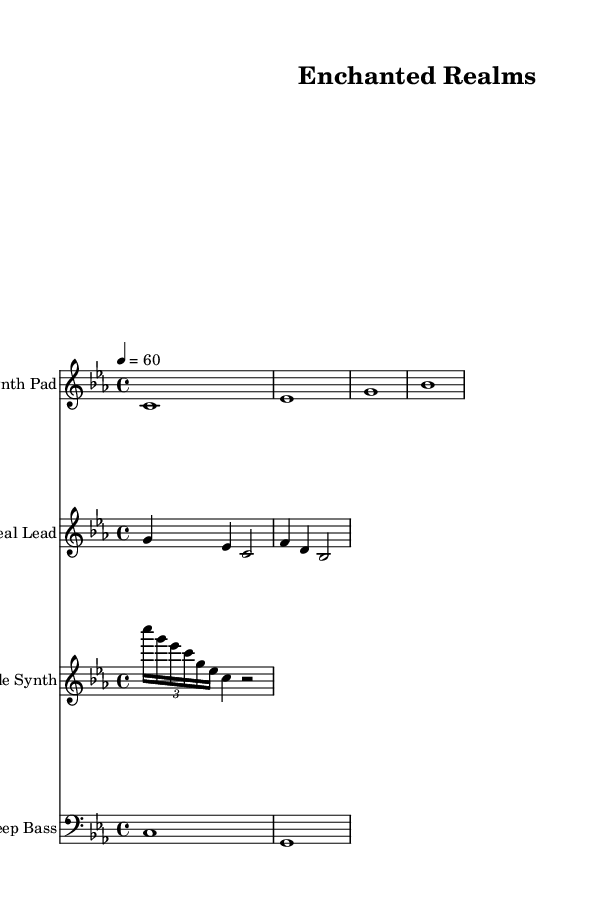What is the key signature of this music? The key signature is C minor, which has three flats (B♭, E♭, and A♭). This can be determined by looking at the key signature notation at the beginning of the score.
Answer: C minor What is the time signature of this piece? The time signature is 4/4, which indicates that there are four beats per measure, and each beat is a quarter note. This is found in the notation at the beginning of the music.
Answer: 4/4 What is the tempo marking for this composition? The tempo marking is 60 beats per minute, indicated by the notation "4 = 60" at the beginning of the score. This means the quarter note gets one beat, and the piece is played at a relatively slow pace.
Answer: 60 How many staves are in this score? There are four staves in total, each representing a different instrument: Synth Pad, Ethereal Lead, Sparkle Synth, and Deep Bass. This can be seen by counting the distinct sections labeled with the instrument names.
Answer: 4 What type of instruments are used in this piece? The instruments used are synthesizers, specifically a Synth Pad, Ethereal Lead, Sparkle Synth, and Deep Bass, as indicated by the instrument names at the start of each staff.
Answer: Synthesizers What rhythmic value does the sparkle synth passage primarily feature? The sparkle synth passage predominantly features sixteenth notes, as evidenced by the use of the 'c16' notation in the score, indicating the note duration. This is a characteristic rhythmic element in ambient electronic music.
Answer: Sixteenth notes Which instrument plays the long and sustained notes? The instrument that plays the long and sustained notes is the Synth Pad, as seen in its part where each note lasts for a full measure (whole notes). This contrasts with the more dynamic melodic lines of the other instruments.
Answer: Synth Pad 